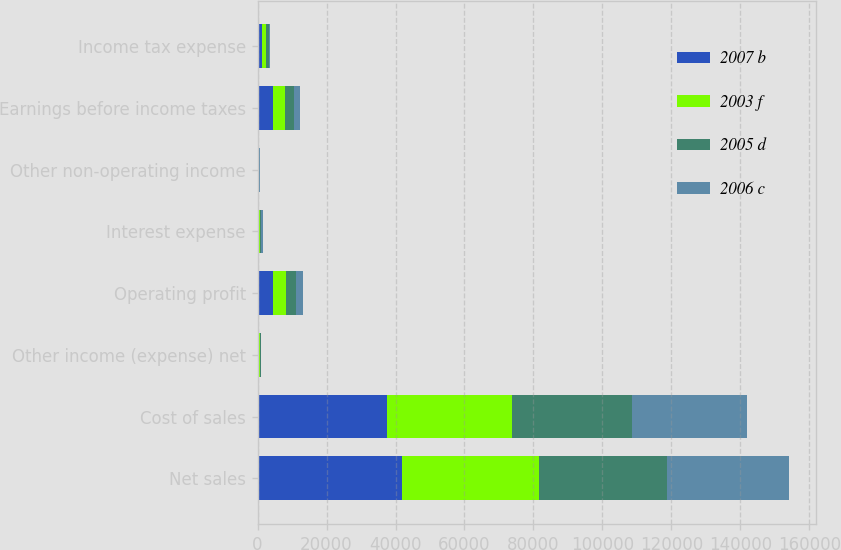Convert chart. <chart><loc_0><loc_0><loc_500><loc_500><stacked_bar_chart><ecel><fcel>Net sales<fcel>Cost of sales<fcel>Other income (expense) net<fcel>Operating profit<fcel>Interest expense<fcel>Other non-operating income<fcel>Earnings before income taxes<fcel>Income tax expense<nl><fcel>2007 b<fcel>41862<fcel>37628<fcel>293<fcel>4527<fcel>352<fcel>193<fcel>4368<fcel>1335<nl><fcel>2003 f<fcel>39620<fcel>36186<fcel>336<fcel>3770<fcel>361<fcel>183<fcel>3592<fcel>1063<nl><fcel>2005 d<fcel>37213<fcel>34676<fcel>316<fcel>2853<fcel>370<fcel>133<fcel>2616<fcel>791<nl><fcel>2006 c<fcel>35526<fcel>33558<fcel>171<fcel>2139<fcel>425<fcel>50<fcel>1664<fcel>398<nl></chart> 